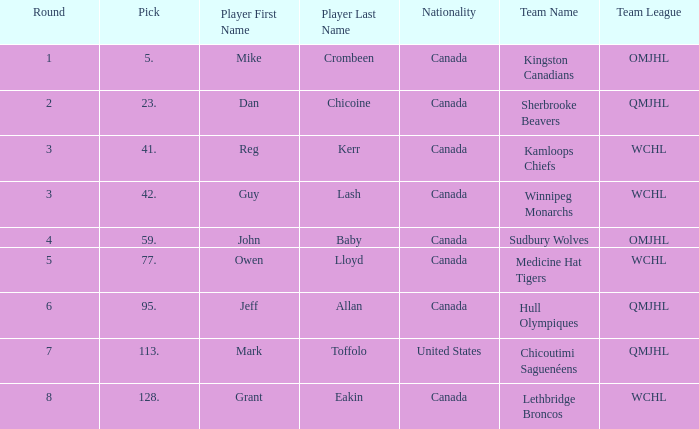Which College/junior/club team has a Round of 2? Sherbrooke Beavers ( QMJHL ). 